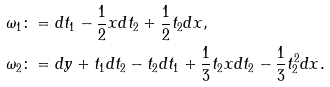<formula> <loc_0><loc_0><loc_500><loc_500>\omega _ { 1 } \colon & = d t _ { 1 } - \frac { 1 } { 2 } x d t _ { 2 } + \frac { 1 } { 2 } t _ { 2 } d x , \\ \omega _ { 2 } \colon & = d y + t _ { 1 } d t _ { 2 } - t _ { 2 } d t _ { 1 } + \frac { 1 } { 3 } t _ { 2 } x d t _ { 2 } - \frac { 1 } { 3 } t _ { 2 } ^ { 2 } d x .</formula> 